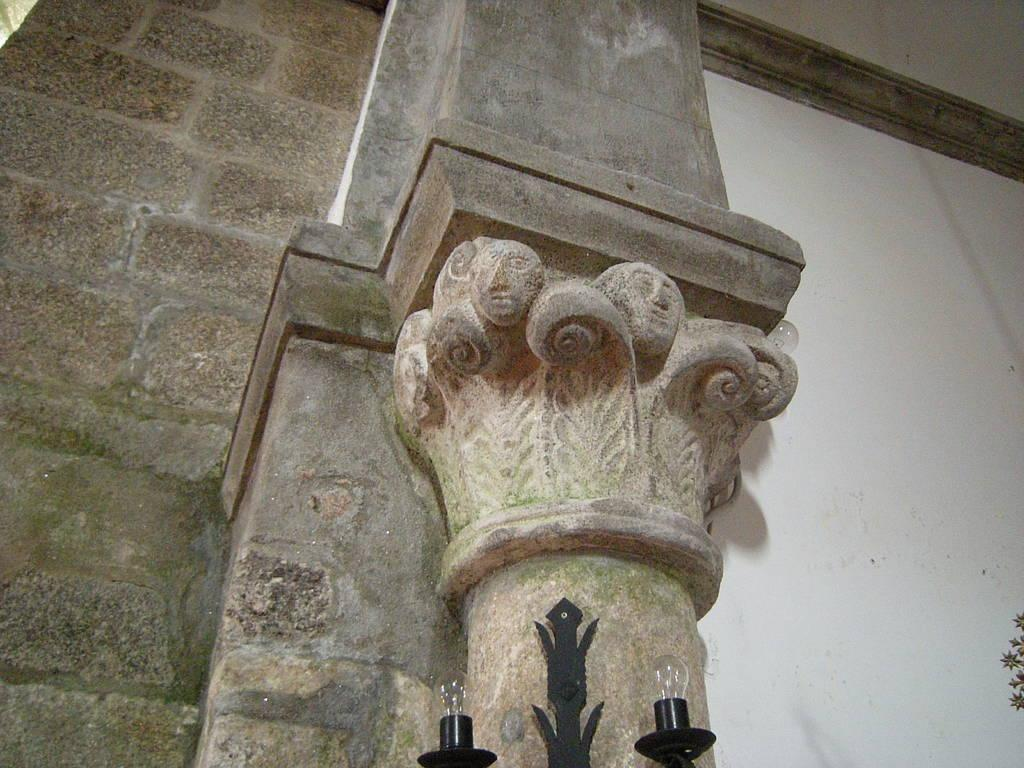What type of structure can be seen in the image? There is a wall and a pillar in the image. What can be used for illumination in the image? There are lights visible in the image. Can you see any pain or discomfort on the faces of the people in the image? There are no people present in the image, so it is not possible to determine if they are experiencing pain or discomfort. 